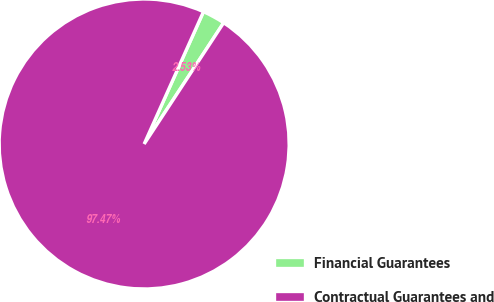<chart> <loc_0><loc_0><loc_500><loc_500><pie_chart><fcel>Financial Guarantees<fcel>Contractual Guarantees and<nl><fcel>2.53%<fcel>97.47%<nl></chart> 